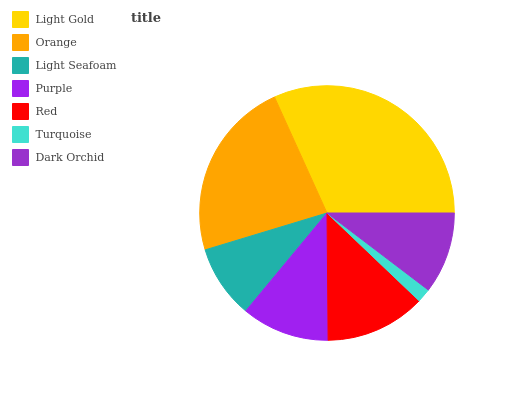Is Turquoise the minimum?
Answer yes or no. Yes. Is Light Gold the maximum?
Answer yes or no. Yes. Is Orange the minimum?
Answer yes or no. No. Is Orange the maximum?
Answer yes or no. No. Is Light Gold greater than Orange?
Answer yes or no. Yes. Is Orange less than Light Gold?
Answer yes or no. Yes. Is Orange greater than Light Gold?
Answer yes or no. No. Is Light Gold less than Orange?
Answer yes or no. No. Is Purple the high median?
Answer yes or no. Yes. Is Purple the low median?
Answer yes or no. Yes. Is Red the high median?
Answer yes or no. No. Is Red the low median?
Answer yes or no. No. 